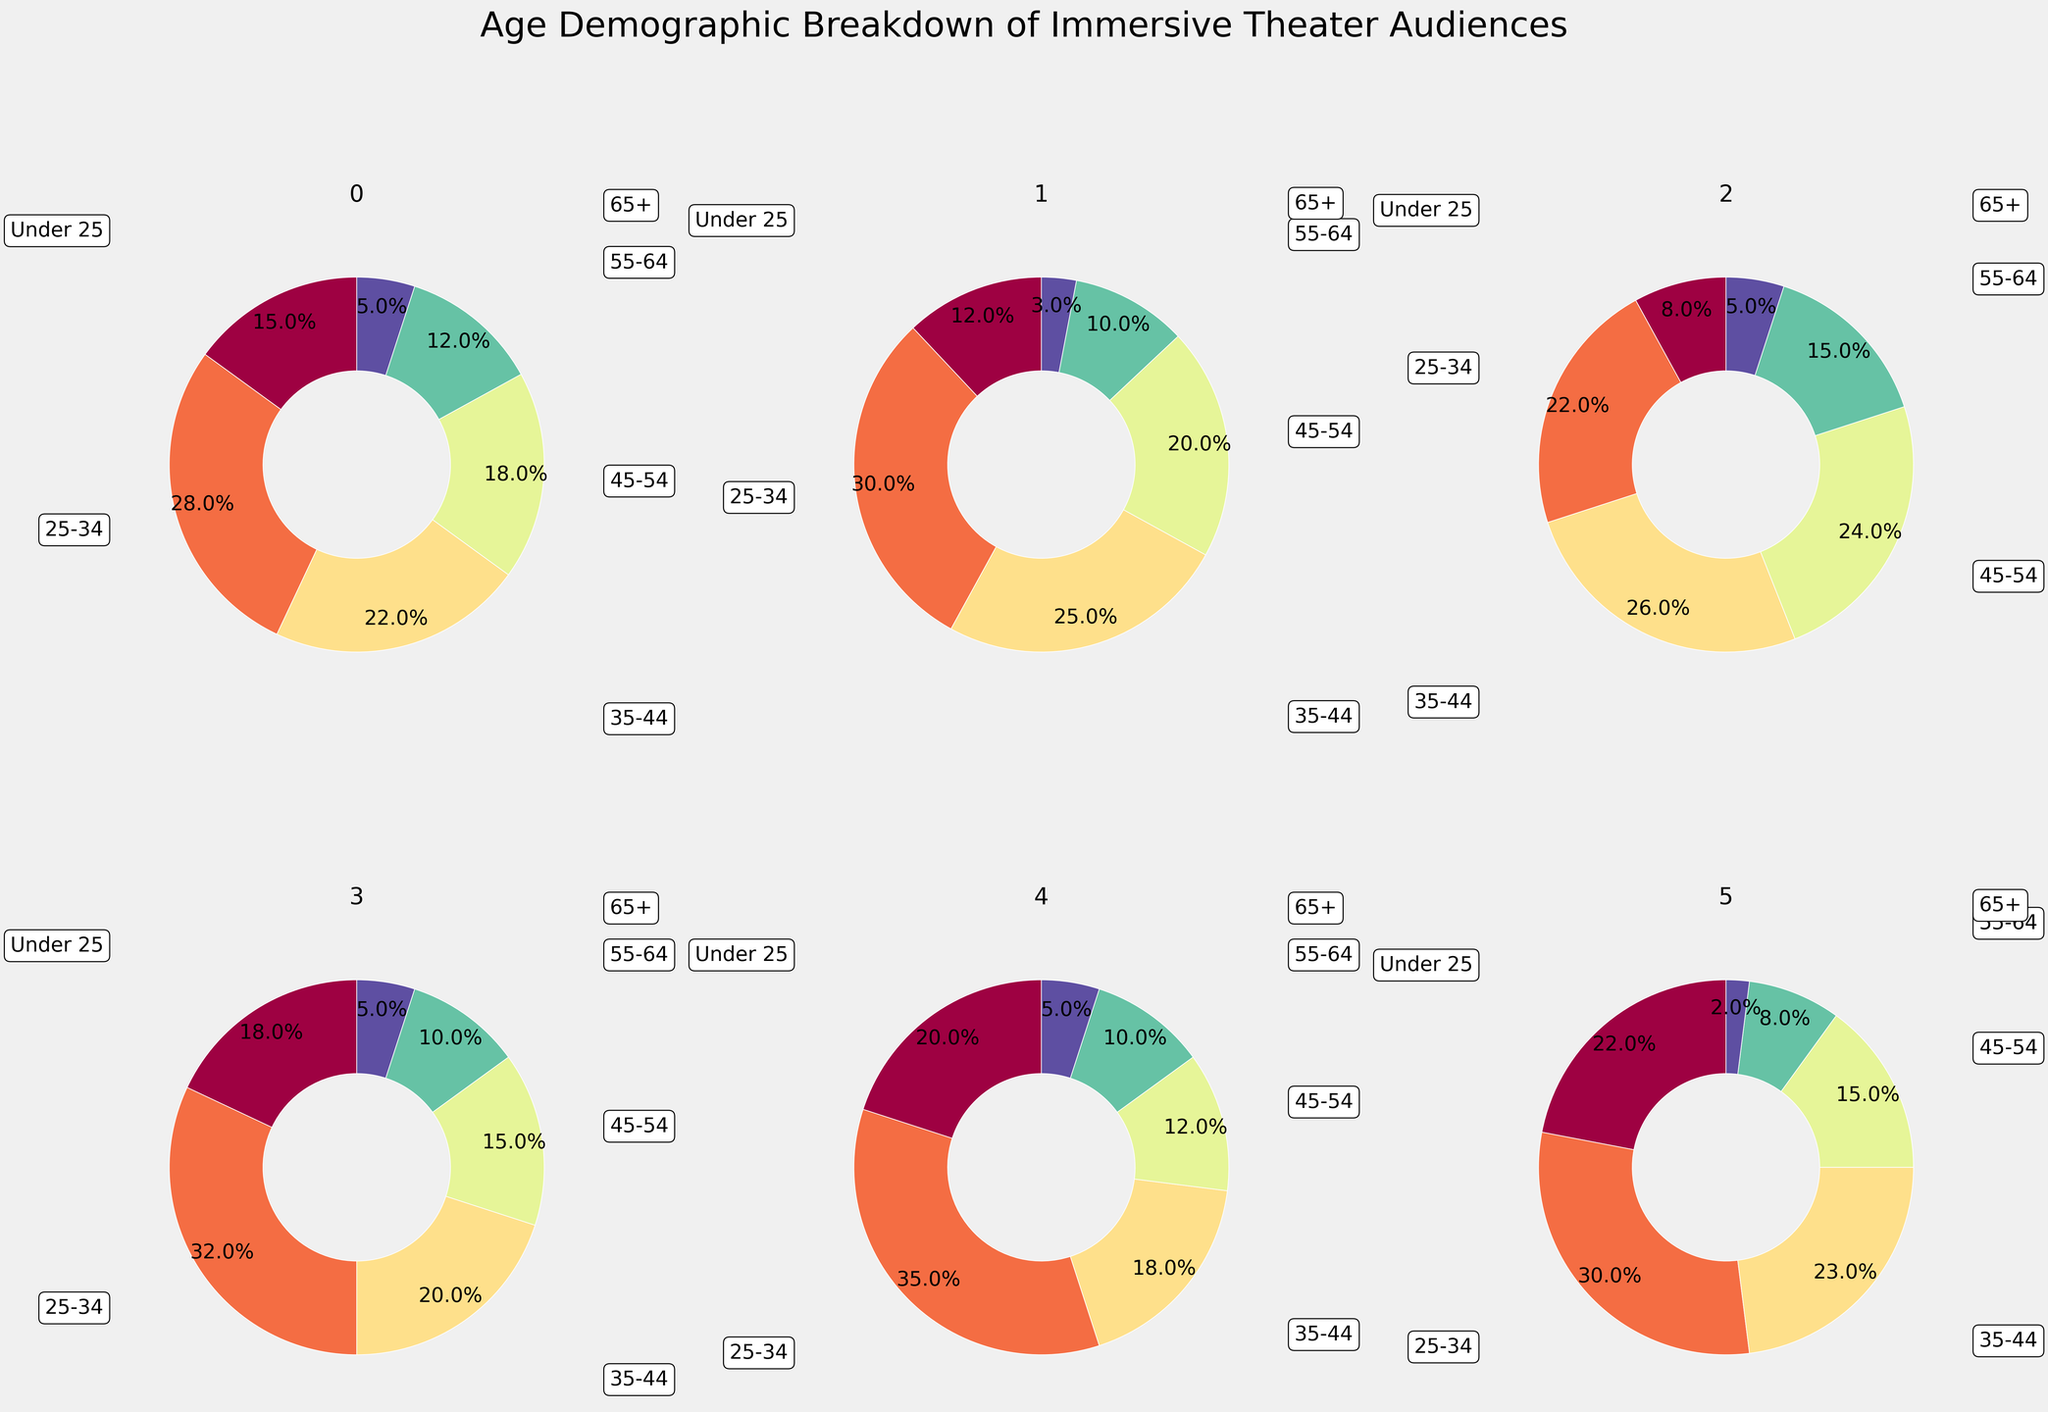what are the six age groups represented in the pie charts? The title for each subplot indicates that the data is for different immersive theater shows, and each pie chart has segments labeled with age group names. The six age groups are 'Under 25', '25-34', '35-44', '45-54', '55-64', and '65+'.
Answer: 'Under 25', '25-34', '35-44', '45-54', '55-64', '65+' Which theater has the highest percentage of attendees aged 25-34? By looking at the percentage segments for the age group '25-34' across all subplots, the biggest slice of pie for '25-34' is in 'Punchdrunk's The Drowned Man', showing it has the highest percentage.
Answer: Punchdrunk's The Drowned Man What is the age group with the smallest segment for 'Then She Fell'? By inspecting the pie chart for 'Then She Fell', the smallest slice on the pie chart corresponds to the '65+' age group, as indicated by its narrow wedge.
Answer: 65+ How does the '35-44' age group distribution compare between 'Sleep No More' and 'Meow Wolf's House of Eternal Return'? For 'Sleep No More', the '35-44' group makes up the third largest segment. For 'Meow Wolf's House of Eternal Return', the '35-44' segment is also the third largest. By observing the percentage labels, 'Sleep No More' has 22% and 'Meow Wolf's House of Eternal Return' has 23% for the '35-44' age group.
Answer: Similar, 22% vs 23% Which immersive theater show has the least percentage of attendees under the age of 25? By examining the 'Under 25' segments across the subplots, 'The Jungle' has the smallest wedge for 'Under 25' at 8%.
Answer: The Jungle What is the combined percentage of attendees aged 45-54 across all theaters? Sum the '45-54' percentages from each pie chart: Sleep No More (18%) + Then She Fell (20%) + The Jungle (24%) + Punchdrunk's The Drowned Man (15%) + You Me Bum Bum Train (12%) + Meow Wolf's House of Eternal Return (15%). Adding these, 18 + 20 + 24 + 15 + 12 + 15 = 104%.
Answer: 104% Which two theater shows have the most similar age distributions for the '55-64' age group? By comparing the percentages for the '55-64' age group across all the theaters, 'Sleep No More' (12%) and 'Meow Wolf's House of Eternal Return' (8%) have relatively close percentages, but 'Punchdrunk's The Drowned Man' (10%) and 'You Me Bum Bum Train' (10%) are identical.
Answer: Punchdrunk's The Drowned Man and You Me Bum Bum Train What age group has the most significant wedge in 'You Me Bum Bum Train'? By examining the pie chart for 'You Me Bum Bum Train', the largest slice is for the '25-34' age group, indicating the highest percentage.
Answer: 25-34 What is the biggest difference between the percentages of the '45-54' age group and the '65+' age group in any single theater? For 'The Jungle', the '45-54' age group has 24% and the '65+' age group has 5%. The difference is 24% - 5% = 19%. This is the largest single difference when compared across other theaters.
Answer: 19% 